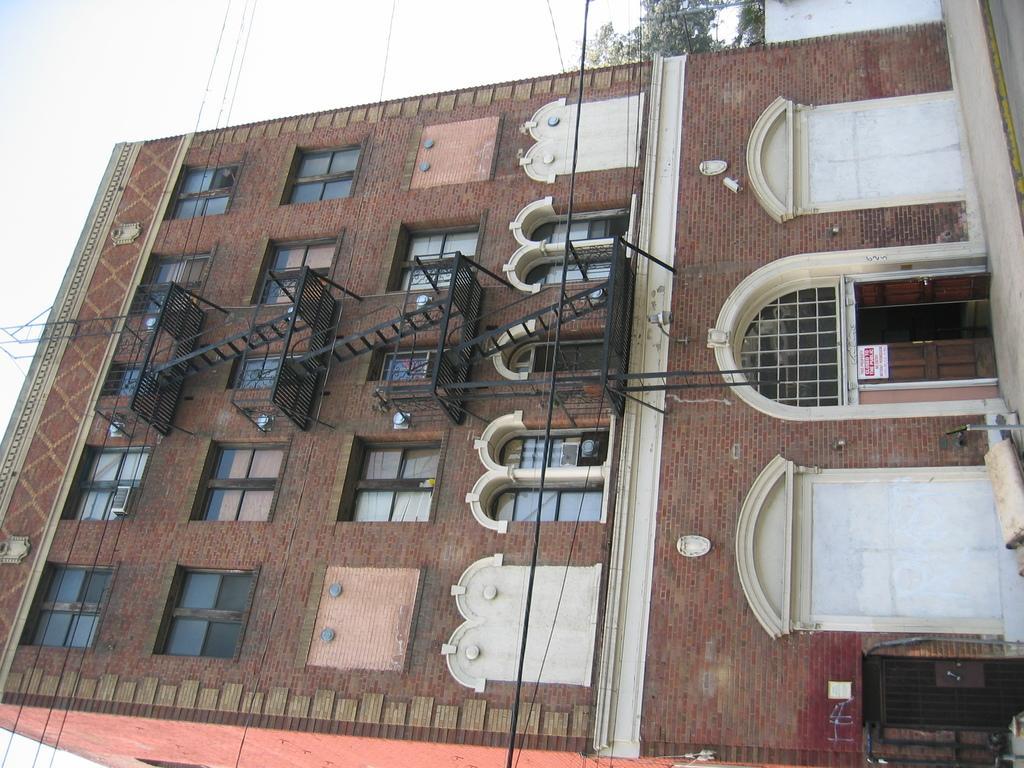How would you summarize this image in a sentence or two? In the picture I can see a brick building, doors, windows, stairs, wires, trees and the sky in the background. 